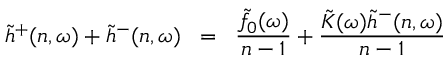<formula> <loc_0><loc_0><loc_500><loc_500>\tilde { h } ^ { + } ( n , \omega ) + \tilde { h } ^ { - } ( n , \omega ) \, = \, \frac { \tilde { f } _ { 0 } ( \omega ) } { n - 1 } + \frac { \tilde { K } ( \omega ) \tilde { h } ^ { - } ( n , \omega ) } { n - 1 }</formula> 